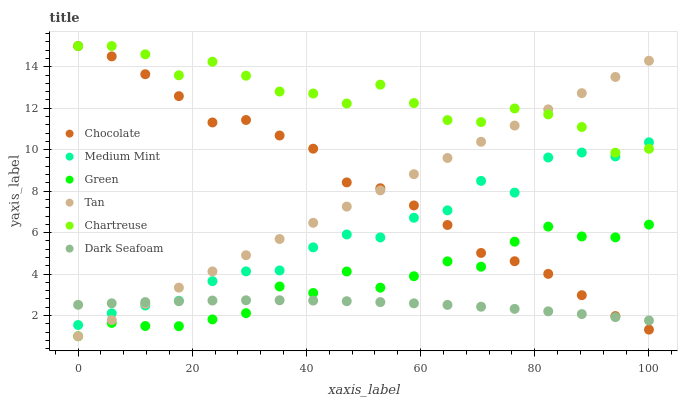Does Dark Seafoam have the minimum area under the curve?
Answer yes or no. Yes. Does Chartreuse have the maximum area under the curve?
Answer yes or no. Yes. Does Chocolate have the minimum area under the curve?
Answer yes or no. No. Does Chocolate have the maximum area under the curve?
Answer yes or no. No. Is Tan the smoothest?
Answer yes or no. Yes. Is Medium Mint the roughest?
Answer yes or no. Yes. Is Dark Seafoam the smoothest?
Answer yes or no. No. Is Dark Seafoam the roughest?
Answer yes or no. No. Does Green have the lowest value?
Answer yes or no. Yes. Does Dark Seafoam have the lowest value?
Answer yes or no. No. Does Chartreuse have the highest value?
Answer yes or no. Yes. Does Dark Seafoam have the highest value?
Answer yes or no. No. Is Green less than Chartreuse?
Answer yes or no. Yes. Is Chartreuse greater than Green?
Answer yes or no. Yes. Does Chartreuse intersect Medium Mint?
Answer yes or no. Yes. Is Chartreuse less than Medium Mint?
Answer yes or no. No. Is Chartreuse greater than Medium Mint?
Answer yes or no. No. Does Green intersect Chartreuse?
Answer yes or no. No. 